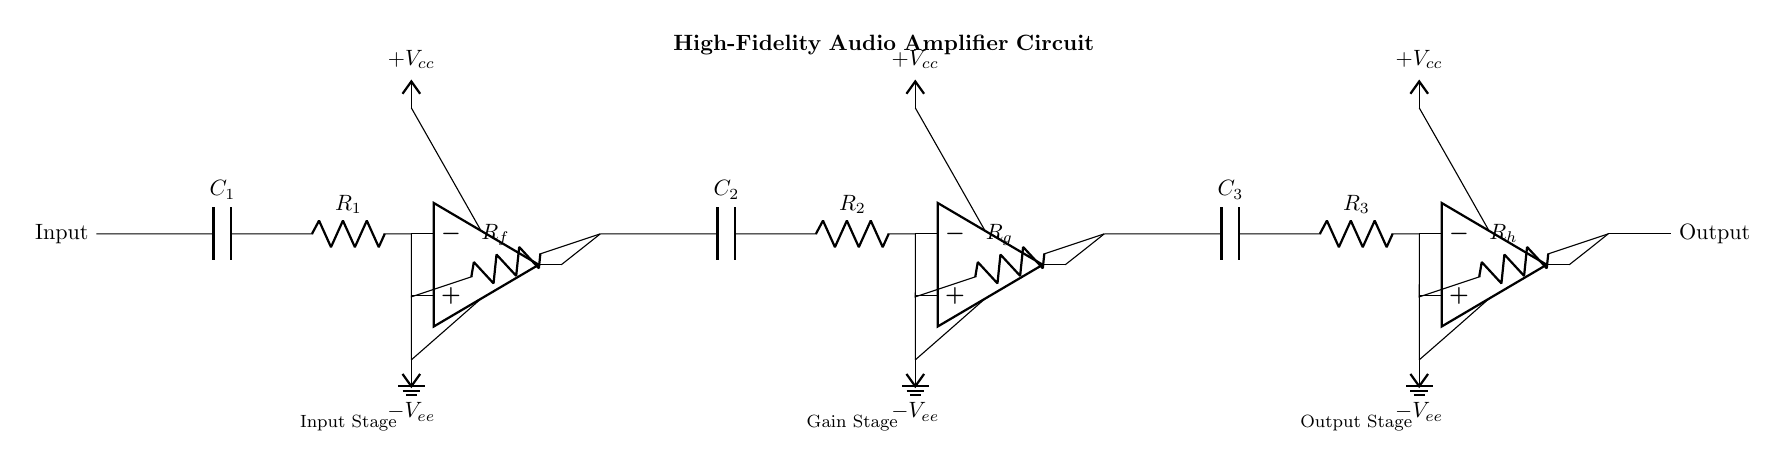What is the total number of operational amplifiers used in this circuit? Counting the distinct operational amplifier symbols present in the diagram, there are three distinct op-amps labeled at the input, gain, and output stages.
Answer: three What component is used in the input stage to block DC? Looking at the input stage, the capacitor labeled C1 is present, which serves to block any DC offset while allowing AC signals to pass through.
Answer: Capacitor C1 What is the function of resistor Rf in the circuit? Rf is connected between the inverting input and the output of the first op-amp; it functions as a feedback resistor, determining the gain of the amplifier by configuring the feedback path.
Answer: Feedback resistor What is the role of the power supply voltages in the circuit? The circuit is powered by dual supply voltages indicated as +Vcc and -Vee; they are essential for allowing the op-amps to output a signal that swings both above and below ground, which is necessary for audio amplification.
Answer: Dual supply voltages How many capacitors are used in the amplifier circuit? By examining the circuit, there are three capacitors labeled C1, C2, and C3 used throughout the stages for coupling, filtering, or stability.
Answer: three What stage comes after the gain stage in the amplifier circuit? The circuit flow moves from the input stage to the gain stage and then to the output stage; thus, the stage that follows the gain stage is the output stage.
Answer: Output stage 